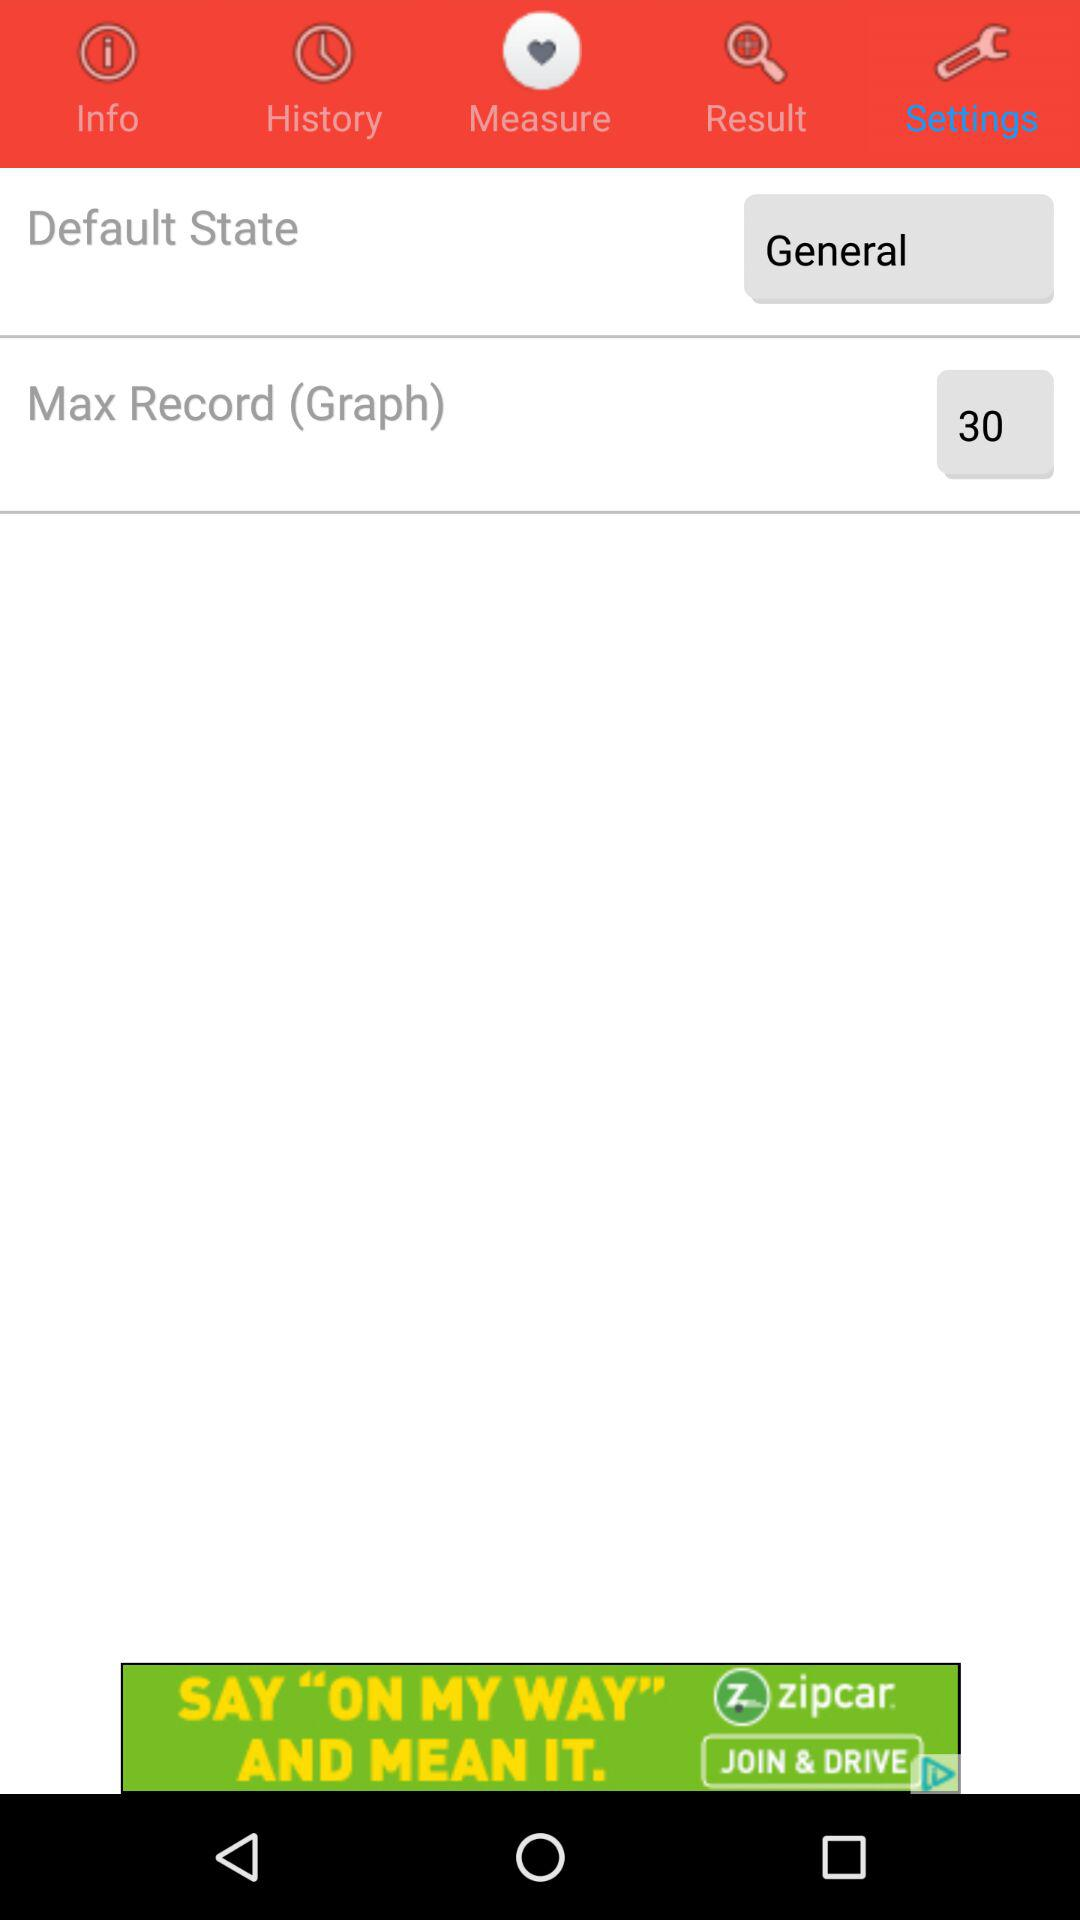Which tab is selected? The selected tab is "Settings". 